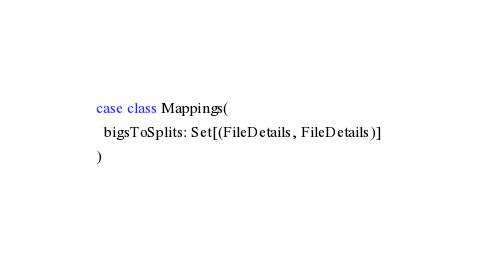<code> <loc_0><loc_0><loc_500><loc_500><_Scala_>case class Mappings(
  bigsToSplits: Set[(FileDetails, FileDetails)]
)

</code> 